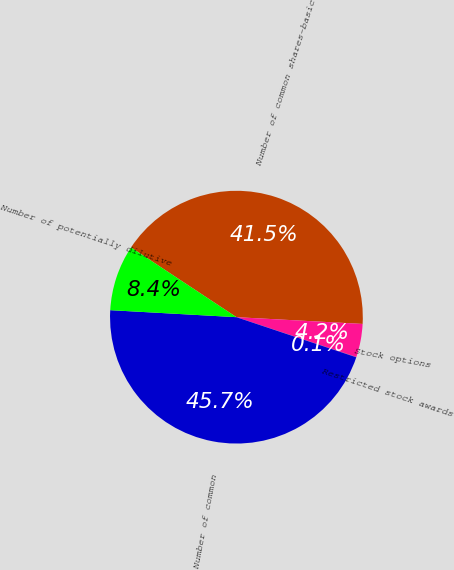Convert chart to OTSL. <chart><loc_0><loc_0><loc_500><loc_500><pie_chart><fcel>Number of common shares-basic<fcel>Stock options<fcel>Restricted stock awards<fcel>Number of common<fcel>Number of potentially dilutive<nl><fcel>41.55%<fcel>4.24%<fcel>0.05%<fcel>45.74%<fcel>8.42%<nl></chart> 